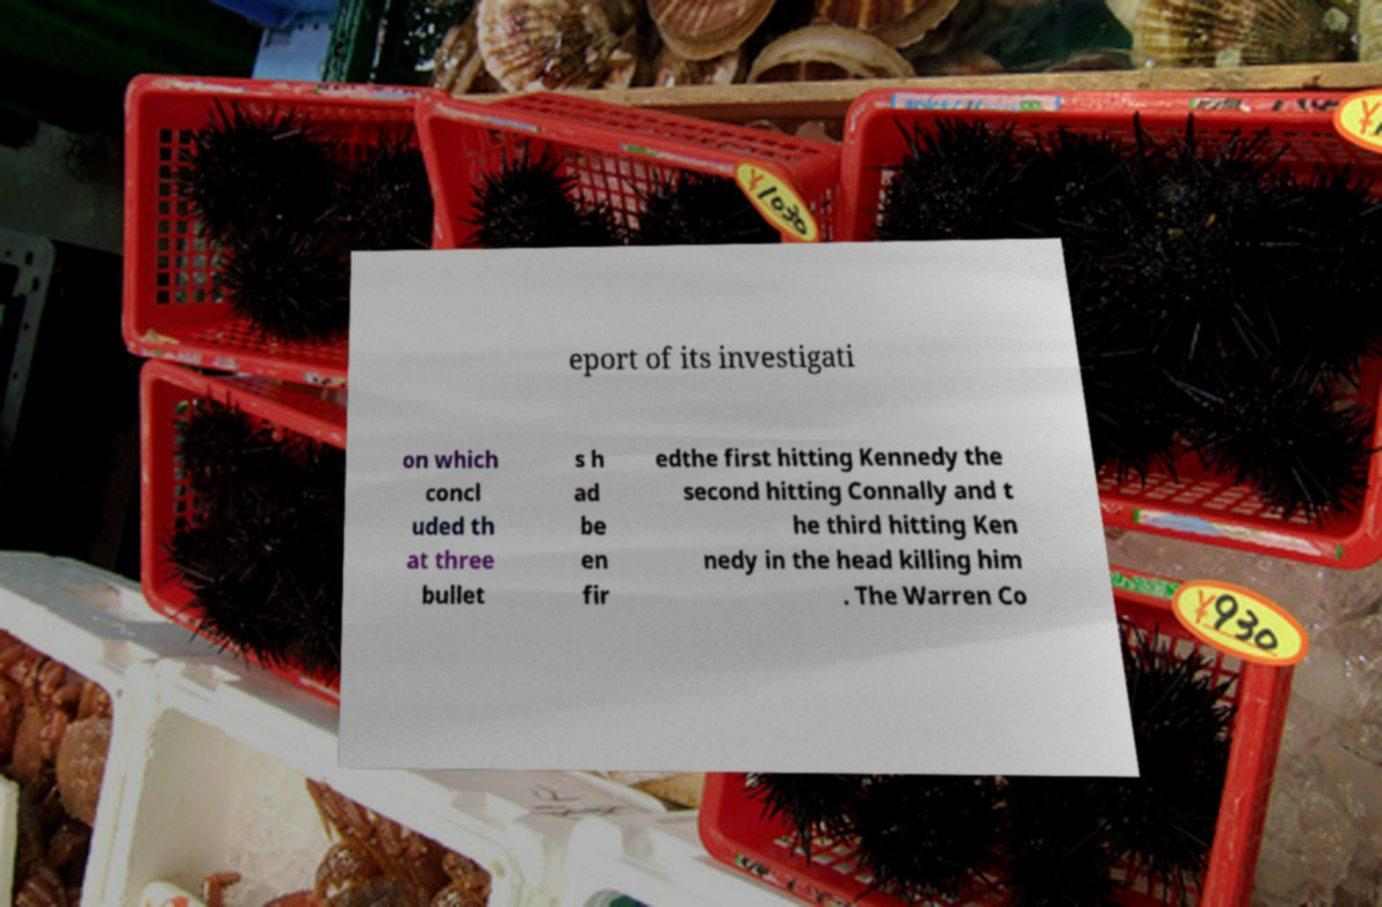For documentation purposes, I need the text within this image transcribed. Could you provide that? eport of its investigati on which concl uded th at three bullet s h ad be en fir edthe first hitting Kennedy the second hitting Connally and t he third hitting Ken nedy in the head killing him . The Warren Co 